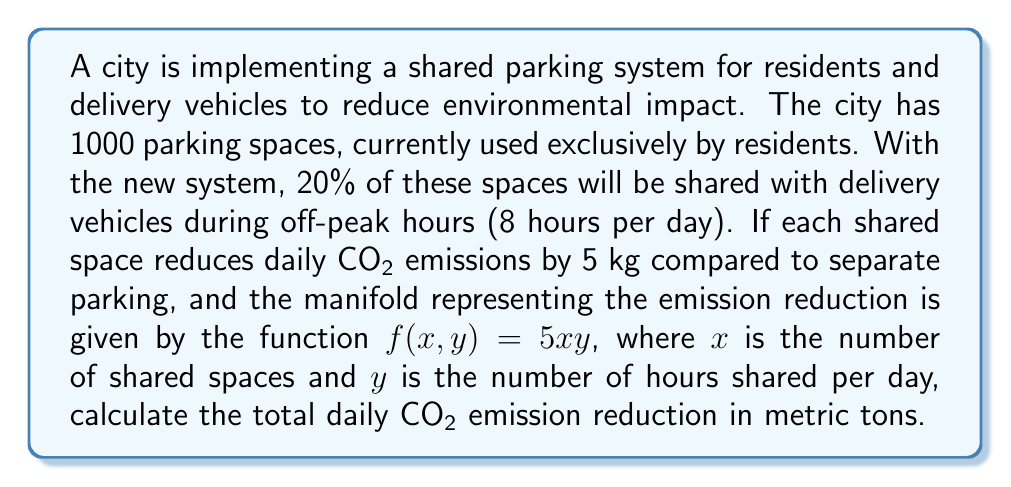Give your solution to this math problem. Let's approach this problem step-by-step:

1) First, we need to determine the number of shared parking spaces:
   20% of 1000 spaces = $1000 \times 0.20 = 200$ spaces

2) We're given that these spaces are shared for 8 hours per day.

3) The manifold function for emission reduction is:
   $f(x,y) = 5xy$
   where $x$ is the number of shared spaces and $y$ is the number of hours shared per day.

4) Let's plug in our values:
   $f(200, 8) = 5 \times 200 \times 8 = 8000$ kg CO2 per day

5) To convert from kg to metric tons, we divide by 1000:
   $8000 \div 1000 = 8$ metric tons

Therefore, the total daily CO2 emission reduction is 8 metric tons.

This problem demonstrates how a manifold can be used to model the relationship between multiple variables (in this case, number of spaces and hours shared) and their impact on a quantity of interest (CO2 emissions). The function $f(x,y) = 5xy$ represents a two-dimensional manifold in three-dimensional space, where the height of the manifold at any point $(x,y)$ gives the emission reduction.
Answer: 8 metric tons of CO2 per day 